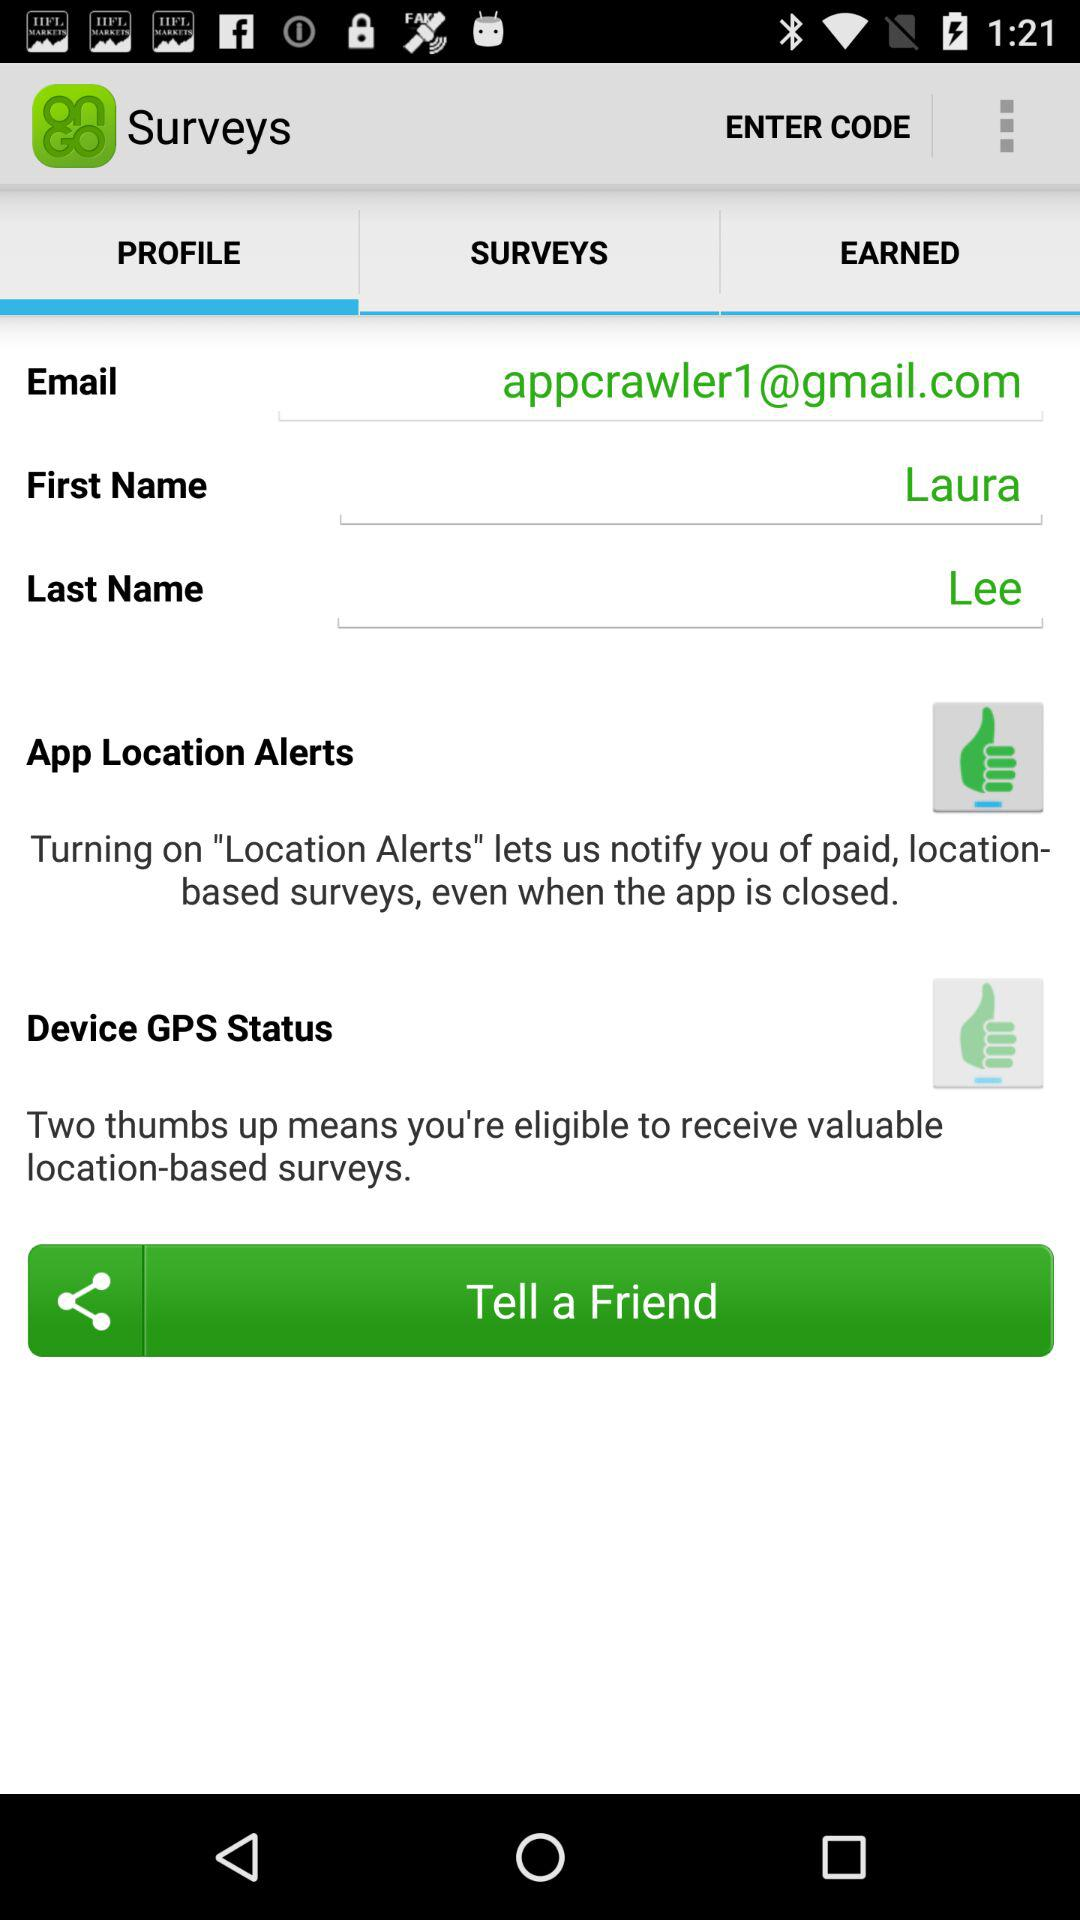What is the email address? The email address is appcrawler1@gmail.com. 